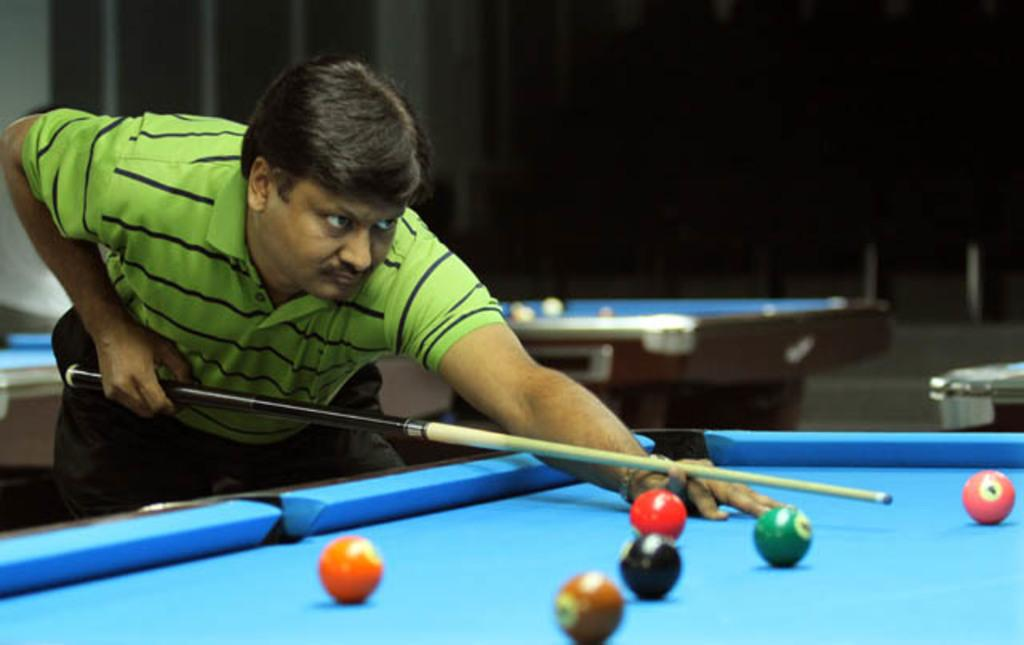Who or what is the main subject in the image? There is a person in the image. What is the person holding in their hands? The person is holding a stick in their hands. What is on the table in the image? There are balls on the table. Can you describe the setting of the image? There is a table in the image, and another table is visible in the background. How does the person compare to the passenger in the image? There is no passenger present in the image, so a comparison cannot be made. 